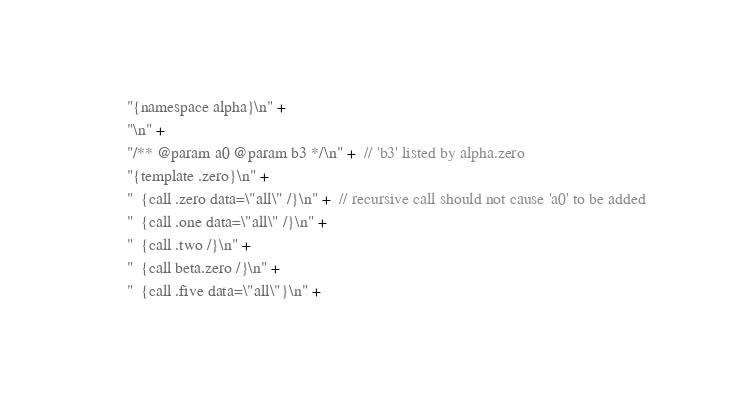Convert code to text. <code><loc_0><loc_0><loc_500><loc_500><_Java_>        "{namespace alpha}\n" +
        "\n" +
        "/** @param a0 @param b3 */\n" +  // 'b3' listed by alpha.zero
        "{template .zero}\n" +
        "  {call .zero data=\"all\" /}\n" +  // recursive call should not cause 'a0' to be added
        "  {call .one data=\"all\" /}\n" +
        "  {call .two /}\n" +
        "  {call beta.zero /}\n" +
        "  {call .five data=\"all\"}\n" +</code> 